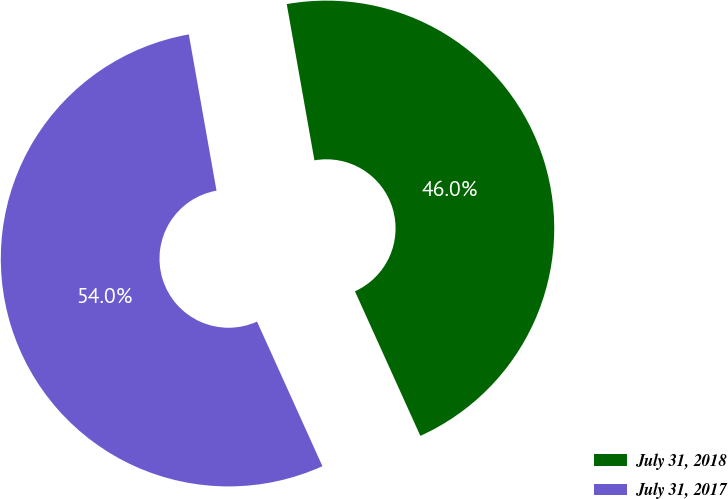Convert chart to OTSL. <chart><loc_0><loc_0><loc_500><loc_500><pie_chart><fcel>July 31, 2018<fcel>July 31, 2017<nl><fcel>46.03%<fcel>53.97%<nl></chart> 